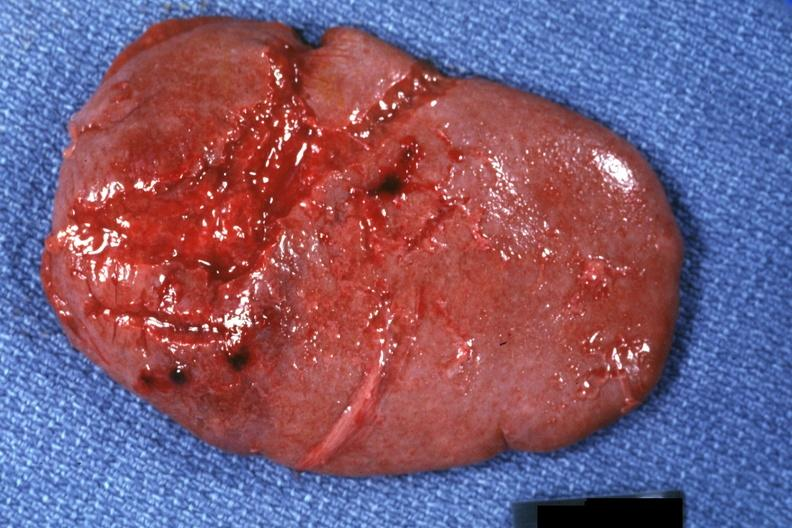s spleen present?
Answer the question using a single word or phrase. Yes 